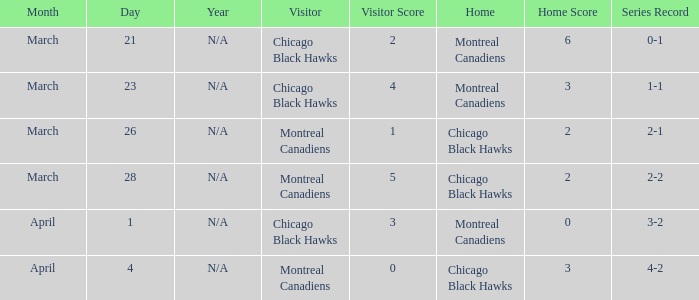Which home team has a record of 3-2? Montreal Canadiens. 